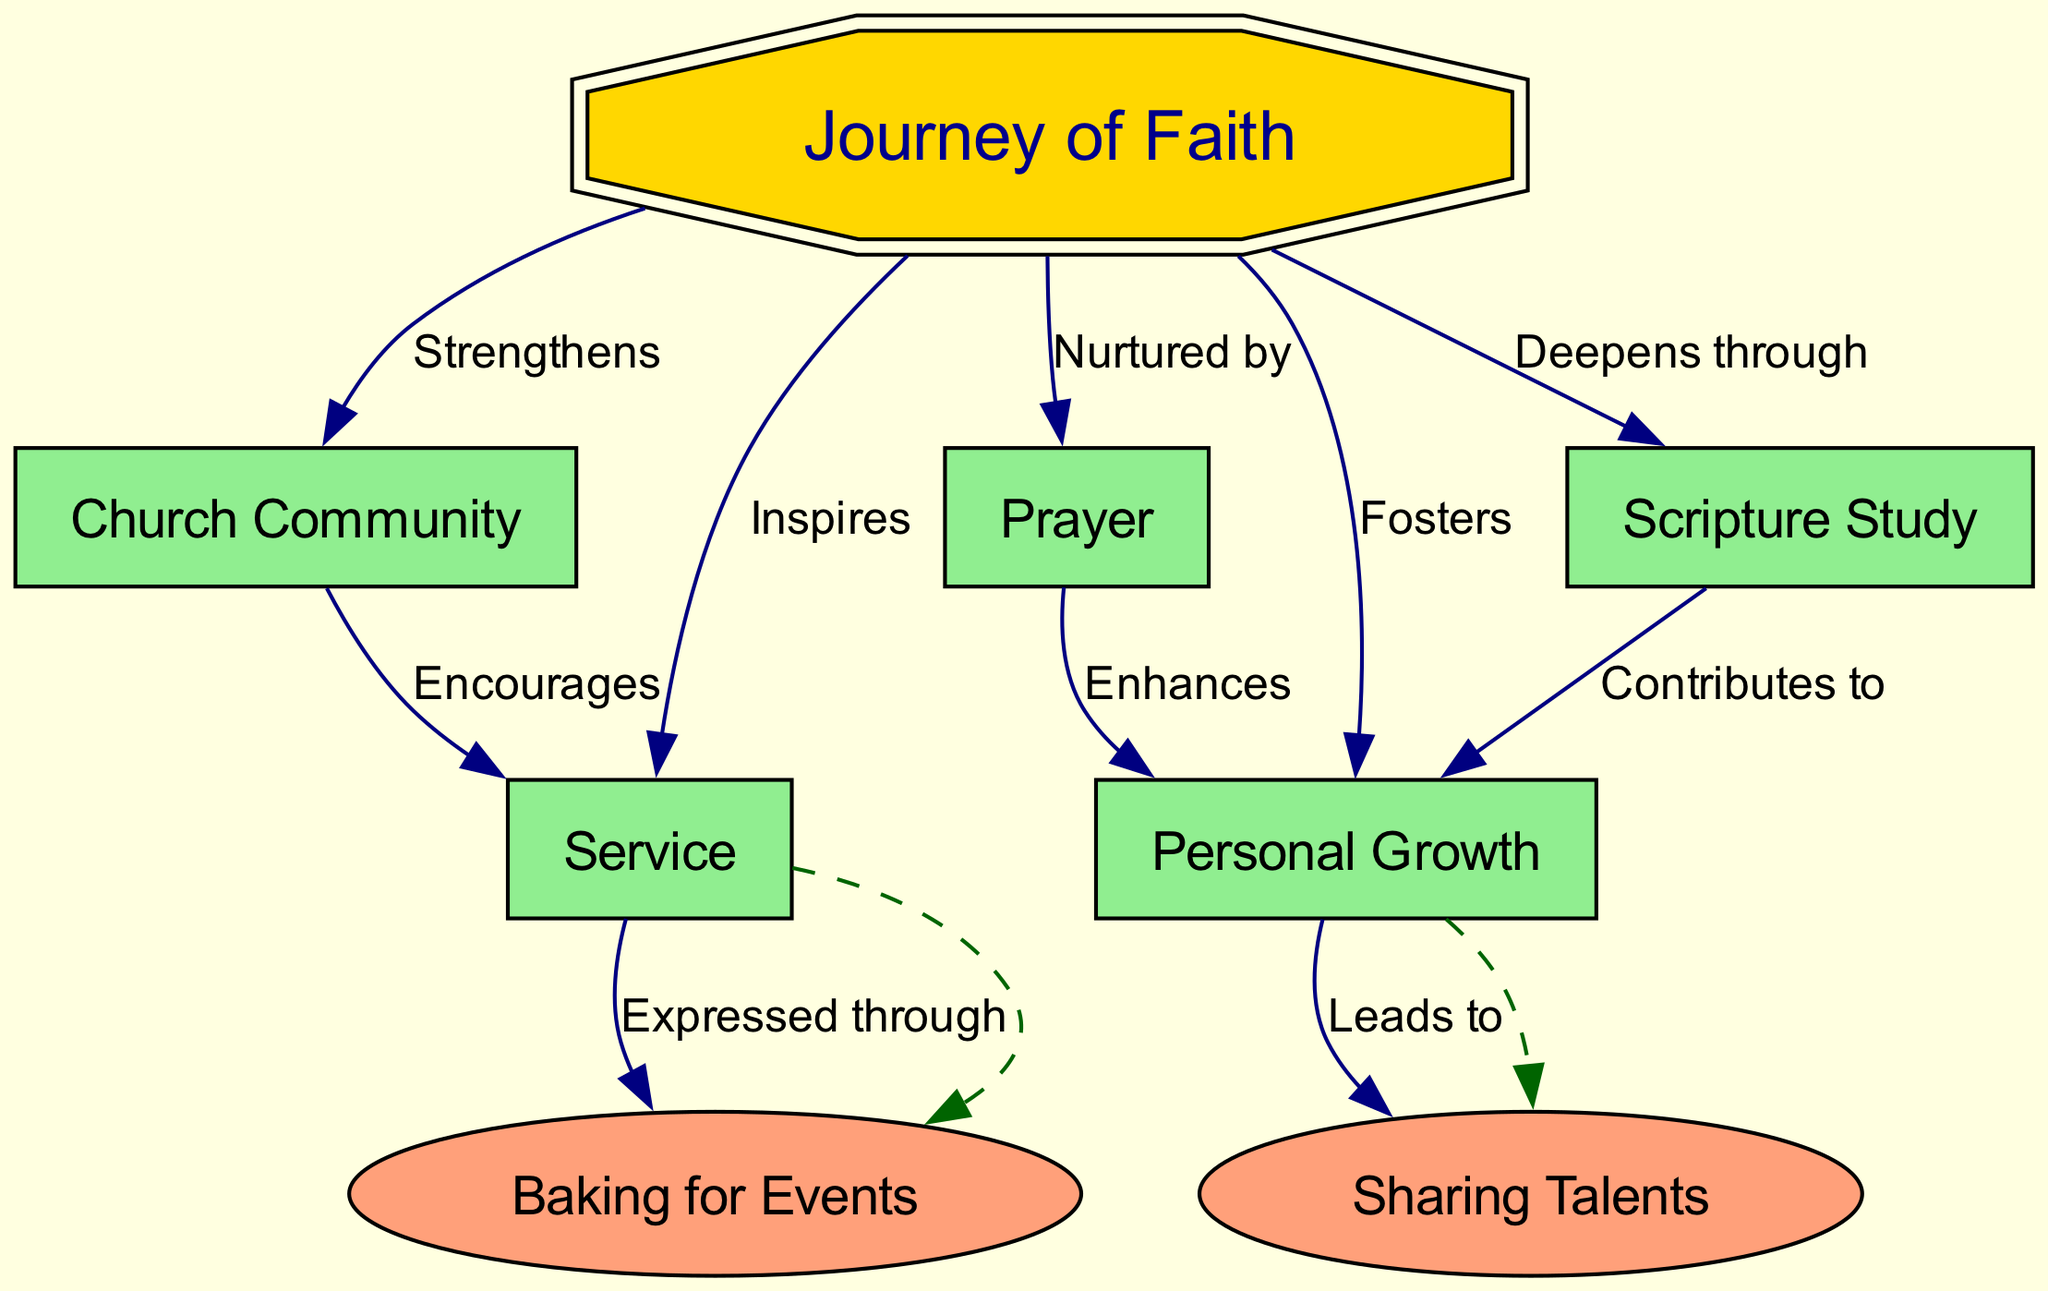What is the central concept of the diagram? The central concept is explicitly stated at the center of the diagram, outlined in a double octagon shape. It is labeled as "Journey of Faith".
Answer: Journey of Faith How many main nodes are connected to the central concept? There are five main nodes listed in the diagram that connect to the central concept, namely "Church Community", "Personal Growth", "Service", "Scripture Study", and "Prayer".
Answer: 5 What relationship does "Service" have with "Church Community"? The diagram shows that "Service" is connected to "Church Community" with a labeled edge indicating a relationship of encouragement. This is a direct connection shown in the labeled edges of the diagram.
Answer: Encourages Which node is directly inspired by the "Journey of Faith"? The edge labels indicate that "Service" is the node directly inspired by the "Journey of Faith", as per the connection shown in the diagram.
Answer: Service How does "Scripture Study" contribute to "Personal Growth"? Within the connections, there is a labeled edge indicating that "Scripture Study" contributes to "Personal Growth". This means there is a direct influence or effect between these two nodes shown in the diagram.
Answer: Contributes to What is expressed through "Service"? According to the diagram, "Baking for Events" is specifically mentioned as being expressed through the "Service" node, indicated by the labeled connection in the sub-nodes section.
Answer: Baking for Events What enhances "Personal Growth"? The diagram indicates that "Prayer" enhances "Personal Growth" through a labeled connection, meaning there is a positive influence shown between these two nodes.
Answer: Enhances What does "Personal Growth" lead to? The edge from "Personal Growth" highlights that it leads to "Sharing Talents", hence this relationship is established directly in the context of the diagram.
Answer: Sharing Talents How are sub-nodes represented in the diagram? The sub-nodes in the diagram are represented as smaller nodes that relate to their parent nodes via dashed edges. This indicates a more specific expression or outcome of the broader concepts.
Answer: Dashed edges 